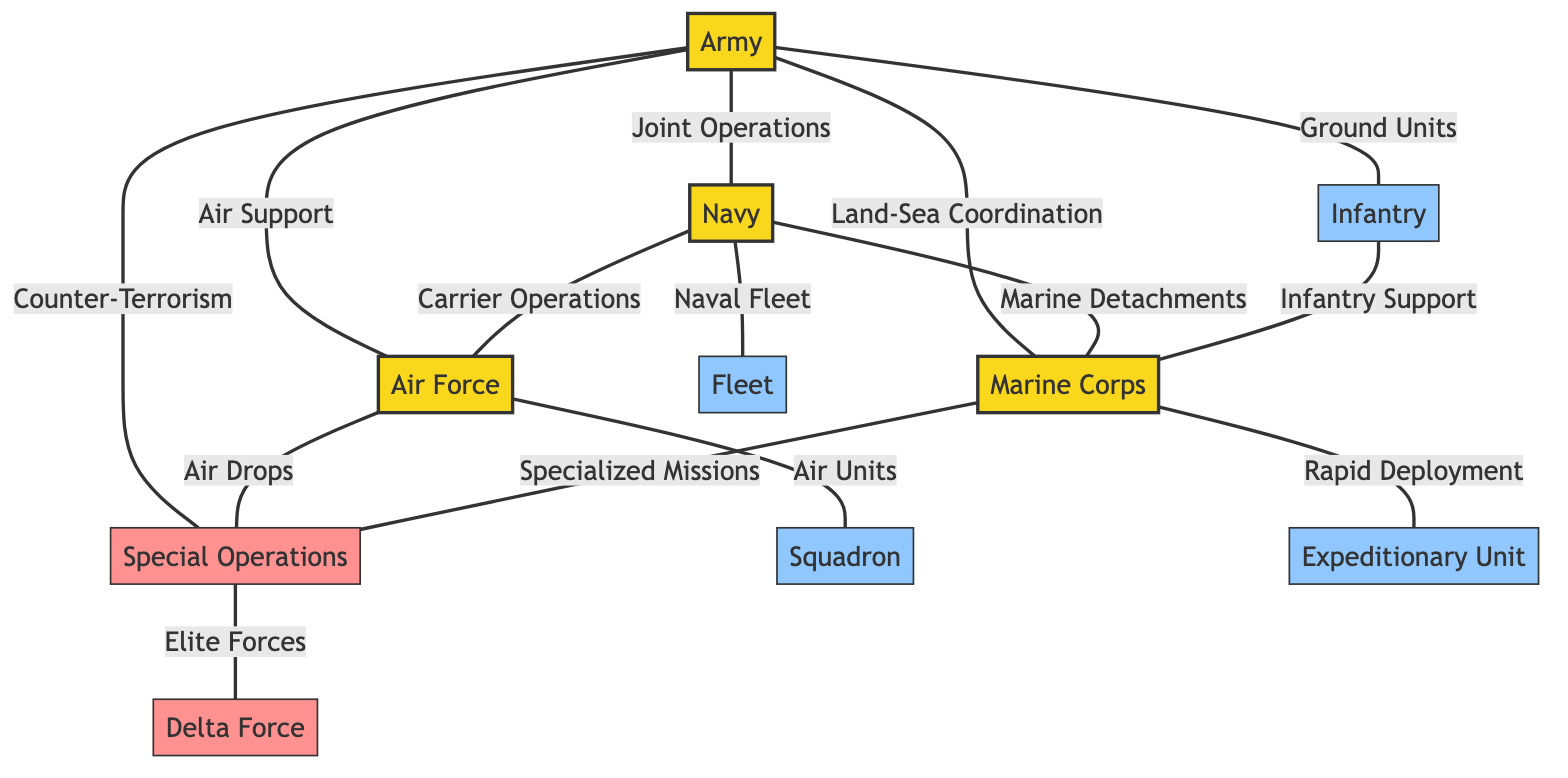What is the total number of nodes in the diagram? To find the total number of nodes, we can count each unique military branch and unit listed in the diagram. There are 10 distinct nodes present: Army, Navy, Air Force, Marine Corps, Special Operations, Infantry, Fleet, Squadron, Expeditionary Unit, and Delta Force.
Answer: 10 Which military branch has a direct relationship with the Infantry? The relationship can be determined by examining the edges connected to the Infantry node. The only direct connection for Infantry is with the Marine Corps, labeled as "Infantry Support."
Answer: Marine Corps How many units are connected to the Special Operations? We look at the edges originating from the Special Operations node to determine how many relationships it has. There is one direct connection to Delta Force, labeled as "Elite Forces". Therefore, there is only one unit connected to it.
Answer: 1 What type of operation connects the Army and Navy? We need to identify the edge that connects Army to Navy. The label of the edge is "Joint Operations," indicating the type of operation that links these two military branches.
Answer: Joint Operations Which two military branches are connected through the relationship labeled "Air Drops"? By looking for the edge labeled "Air Drops," we can identify the two connected nodes. The edge connects the Air Force to Special Operations, indicating those two branches are linked through this specific relationship.
Answer: Air Force and Special Operations What is the relationship between the Marine Corps and Expeditionary Unit? We examine the edges to find if there is a direct connection between the Marine Corps and Expeditionary Unit. The diagram shows that there is no direct edge between them, indicating they are not directly related.
Answer: None How many edges connect the Navy to other branches? Counting the edges linked to the Navy shows its connections to three branches, which are Army, Air Force, and Marine Corps. Hence, there are three edges connecting the Navy to other military branches.
Answer: 3 Which branch has a direct relationship with the Delta Force? Delta Force is connected through one edge to Special Operations as labeled "Elite Forces." Therefore, this branch has a direct connection with Delta Force.
Answer: Special Operations 